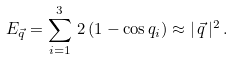<formula> <loc_0><loc_0><loc_500><loc_500>E _ { \vec { q } } = \sum _ { i = 1 } ^ { 3 } \, 2 \, ( 1 - \cos q _ { i } ) \approx | \, \vec { q } \, | ^ { 2 } \, .</formula> 